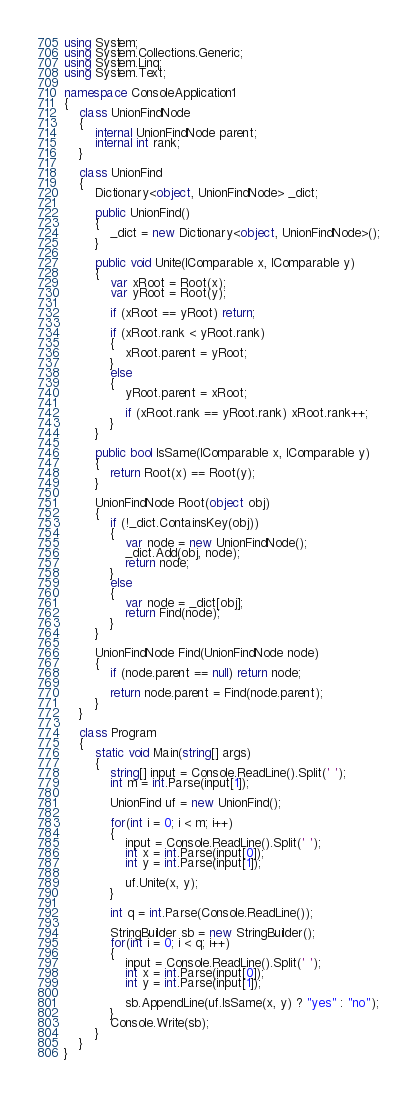<code> <loc_0><loc_0><loc_500><loc_500><_C#_>using System;
using System.Collections.Generic;
using System.Linq;
using System.Text;

namespace ConsoleApplication1
{
    class UnionFindNode
    {
        internal UnionFindNode parent;
        internal int rank;
    }

    class UnionFind
    {
        Dictionary<object, UnionFindNode> _dict;

        public UnionFind()
        {
            _dict = new Dictionary<object, UnionFindNode>();
        }

        public void Unite(IComparable x, IComparable y)
        {
            var xRoot = Root(x);
            var yRoot = Root(y);

            if (xRoot == yRoot) return;

            if (xRoot.rank < yRoot.rank)
            {
                xRoot.parent = yRoot;
            }
            else
            {
                yRoot.parent = xRoot;

                if (xRoot.rank == yRoot.rank) xRoot.rank++;
            }
        }

        public bool IsSame(IComparable x, IComparable y)
        {
            return Root(x) == Root(y);
        }

        UnionFindNode Root(object obj)
        {
            if (!_dict.ContainsKey(obj))
            {
                var node = new UnionFindNode();
                _dict.Add(obj, node);
                return node;
            }
            else
            {
                var node = _dict[obj];
                return Find(node);
            }
        }

        UnionFindNode Find(UnionFindNode node)
        {
            if (node.parent == null) return node;

            return node.parent = Find(node.parent);
        }
    }

    class Program
    {
        static void Main(string[] args)
        {
            string[] input = Console.ReadLine().Split(' ');
            int m = int.Parse(input[1]);

            UnionFind uf = new UnionFind();

            for(int i = 0; i < m; i++)
            {
                input = Console.ReadLine().Split(' ');
                int x = int.Parse(input[0]);
                int y = int.Parse(input[1]);

                uf.Unite(x, y);
            }

            int q = int.Parse(Console.ReadLine());

            StringBuilder sb = new StringBuilder();
            for(int i = 0; i < q; i++)
            {
                input = Console.ReadLine().Split(' ');
                int x = int.Parse(input[0]);
                int y = int.Parse(input[1]);

                sb.AppendLine(uf.IsSame(x, y) ? "yes" : "no");
            }
            Console.Write(sb);
        }
    }
}</code> 